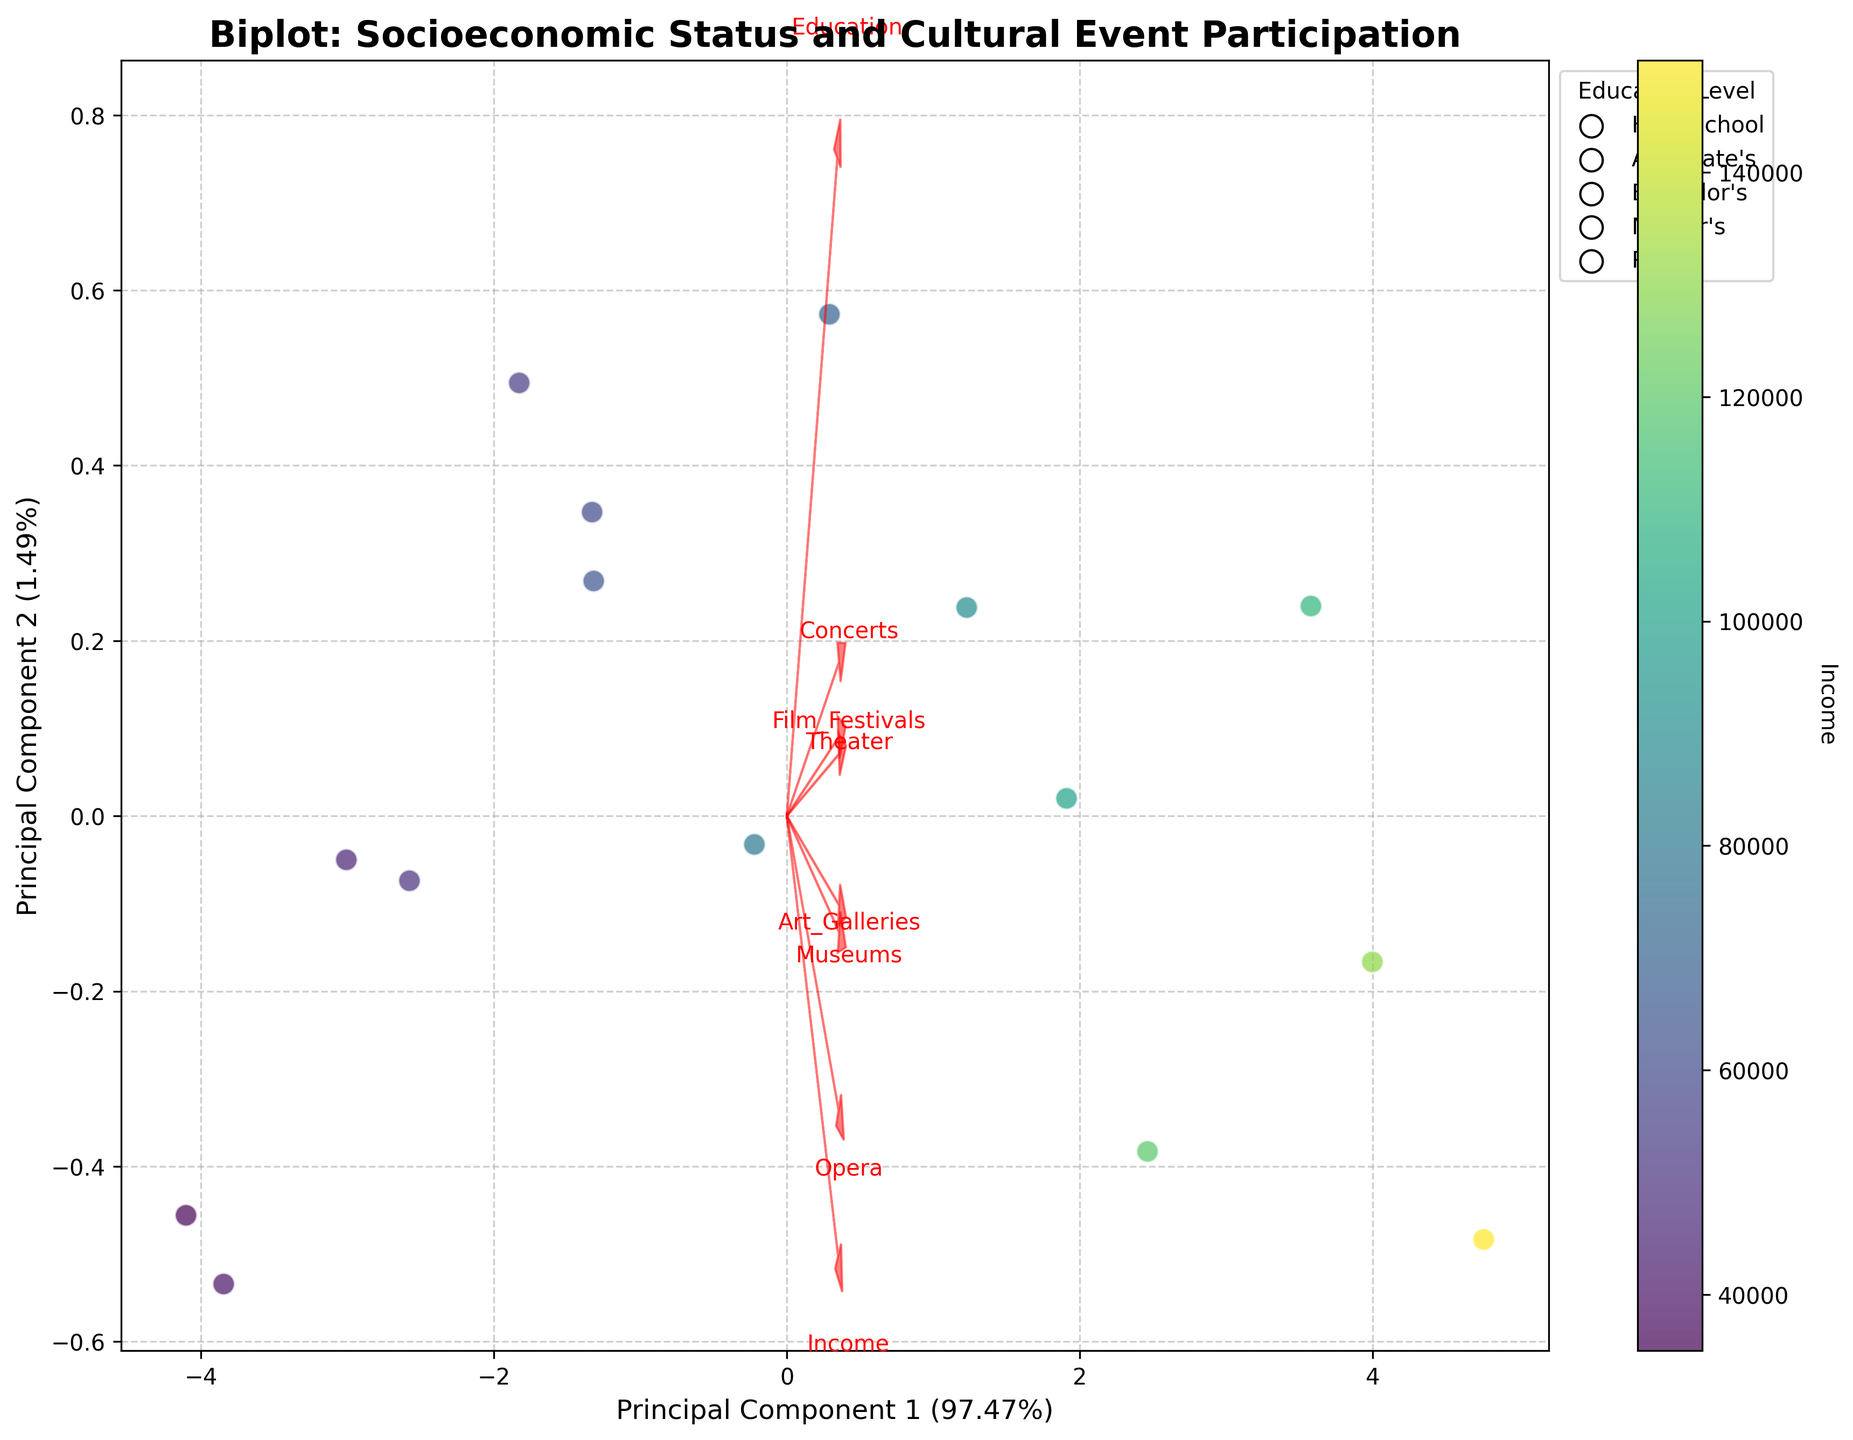What's the title of the figure? The title of the figure is found at the top and usually describes the main subject of the plot. Here, it indicates the correlation between socioeconomic status and cultural event participation.
Answer: Biplot: Socioeconomic Status and Cultural Event Participation How are the data points differentiated in the scatter plot? Data points are color-coded by income and the color intensity varies along a spectrum. They also have edge colors that differentiate them by education levels.
Answer: By income and education levels Which principal component explains more variance in the data? The x-axis and y-axis are labeled with the percentage of variance each principal component explains. The x-axis (Principal Component 1) shows a higher percentage.
Answer: Principal Component 1 Which socioeconomic feature vector points closest to the origin? Feature vectors are represented by arrows. The proximity of the arrow tips to the origin determines which is closest. They point outwards starting from the center.
Answer: Education Which cultural event has the longest feature vector? The length of a feature vector in a biplot indicates the importance of the feature; the longer the arrow, the more significant the feature in explaining the variance.
Answer: Concerts What's the general trend between income level and principal component 1? Data points are color-coded by income and can be observed along the x-axis (Principal Component 1). Darker colors (higher income) generally need to be checked if they are on the right side, indicating a positive correlation.
Answer: Positive correlation How do education levels generally trend along the second principal component? Education levels are indicated by different point edge styles. Observing the y-axis (Principal Component 2) and correlating data points with specific education levels shows the trend.
Answer: Higher along Principal Component 2 Is there a visible correlation between participation in film festivals and visiting art galleries? Arrows for Film Festivals and Art Galleries can be checked to see if they point in a similar direction or are close. Similar directions imply a positive correlation.
Answer: Yes, positive correlation Which data point has the highest participation in Opera? Since Opera is less frequent, high participation can be seen in fewer points. The position of the point corresponding to the highest value along the particular feature vector indicates this.
Answer: The point corresponding to high income, likely near the end of the Opera arrow Can you identify the outlier in terms of cultural event participation? Outliers are points that deviate significantly from the cluster of other points. Analyze the position of all points and see which point lies farthest from the central cluster.
Answer: The point associated with PhD, high income, and high cultural participation 